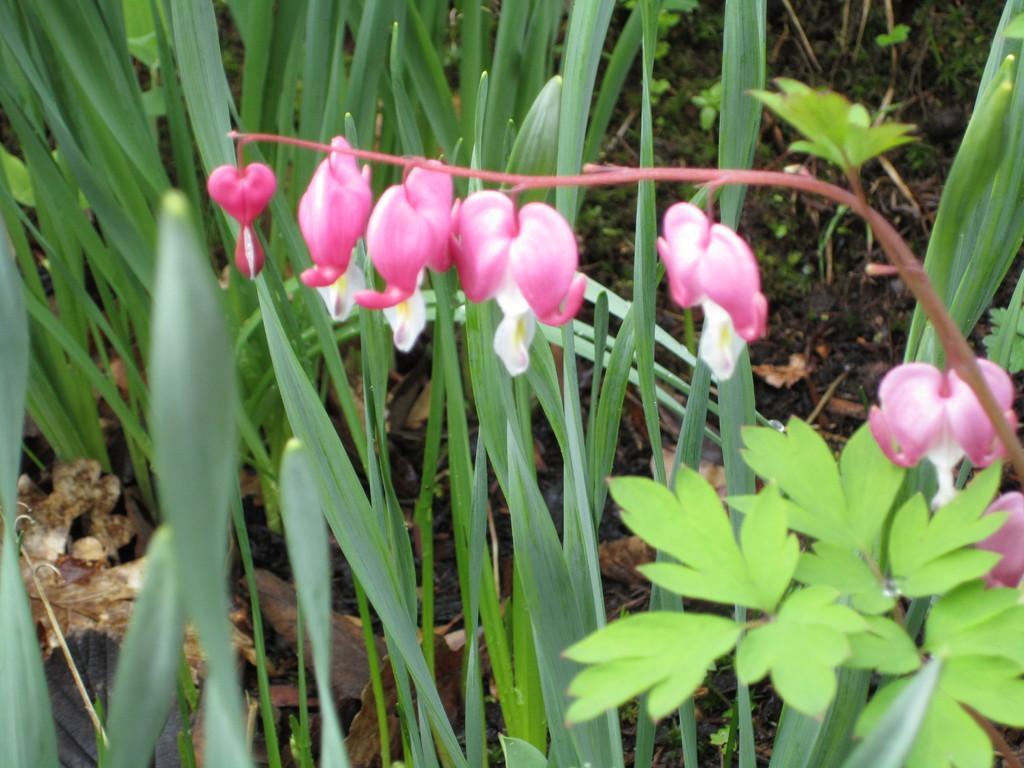Can you describe this image briefly? Here we can see flowers, plant and grass. 